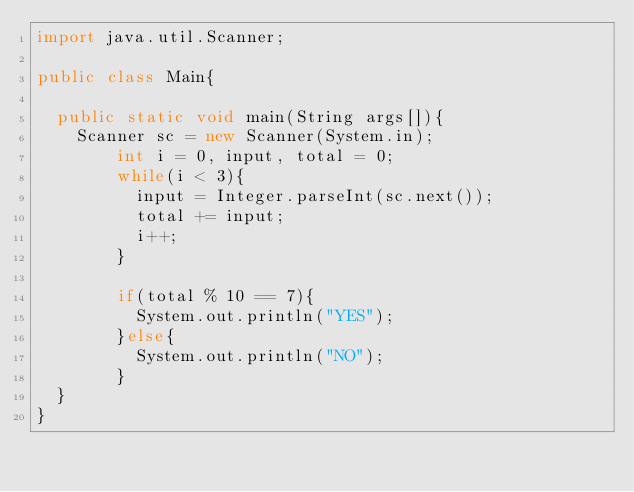Convert code to text. <code><loc_0><loc_0><loc_500><loc_500><_Java_>import java.util.Scanner;

public class Main{
	
	public static void main(String args[]){
		Scanner sc = new Scanner(System.in);
      	int i = 0, input, total = 0;
      	while(i < 3){
          input = Integer.parseInt(sc.next());
          total += input;
          i++;
        }
      
      	if(total % 10 == 7){
        	System.out.println("YES");
        }else{
        	System.out.println("NO");
        }
	}
}
</code> 